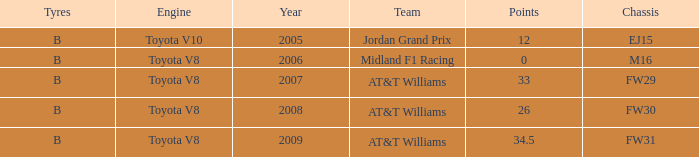What is the low point total after 2006 with an m16 chassis? None. 